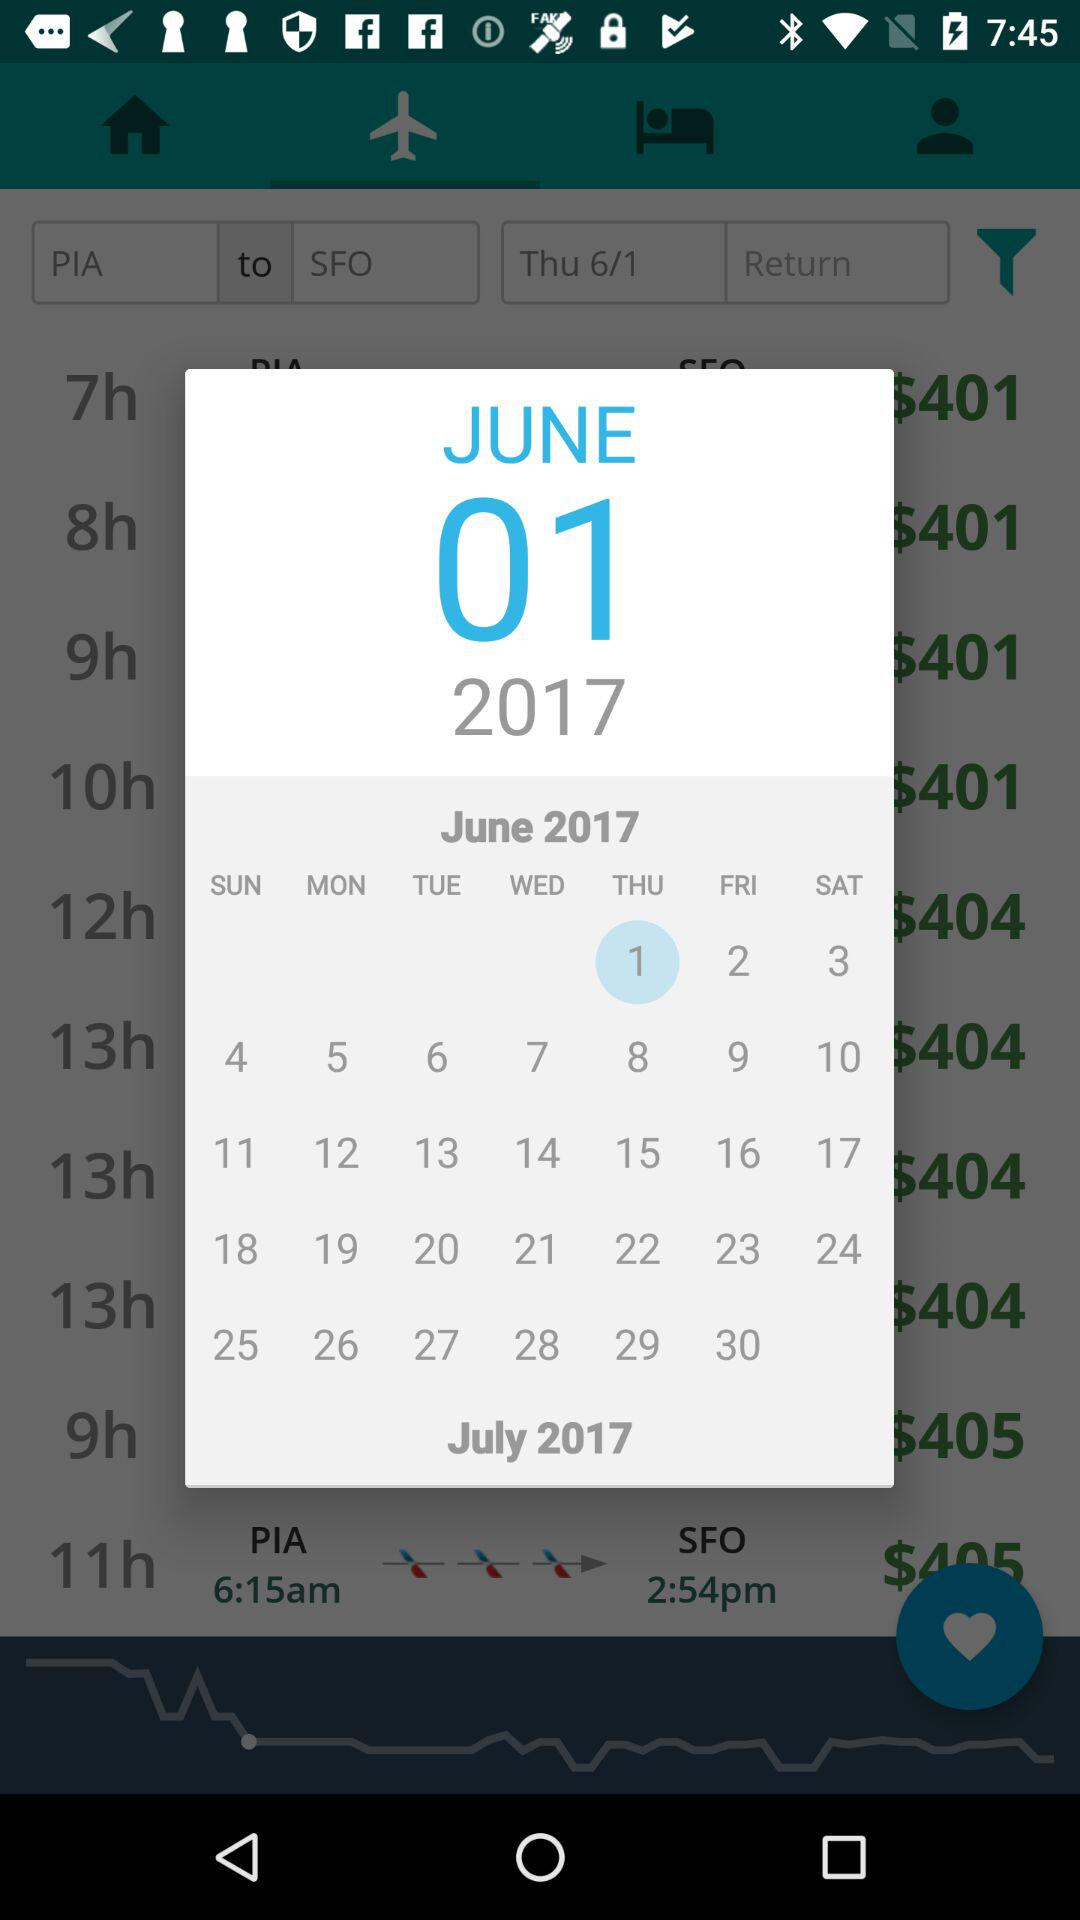What is the departure airport code? The departure airport code is "PIA". 